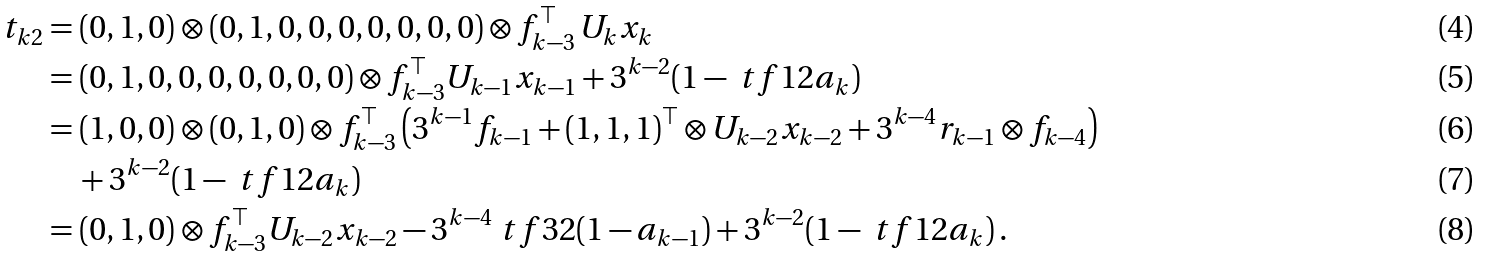<formula> <loc_0><loc_0><loc_500><loc_500>t _ { k 2 } & = ( 0 , 1 , 0 ) \otimes ( 0 , 1 , 0 , 0 , 0 , 0 , 0 , 0 , 0 ) \otimes f _ { k - 3 } ^ { \top } \, U _ { k } x _ { k } \\ & = ( 0 , 1 , 0 , 0 , 0 , 0 , 0 , 0 , 0 ) \otimes f _ { k - 3 } ^ { \top } U _ { k - 1 } x _ { k - 1 } + 3 ^ { k - 2 } ( 1 - \ t f 1 2 a _ { k } ) \\ & = ( 1 , 0 , 0 ) \otimes ( 0 , 1 , 0 ) \otimes f _ { k - 3 } ^ { \top } \left ( 3 ^ { k - 1 } f _ { k - 1 } + ( 1 , 1 , 1 ) ^ { \top } \otimes U _ { k - 2 } x _ { k - 2 } + 3 ^ { k - 4 } r _ { k - 1 } \otimes f _ { k - 4 } \right ) \\ & \quad + 3 ^ { k - 2 } ( 1 - \ t f 1 2 a _ { k } ) \\ & = ( 0 , 1 , 0 ) \otimes f _ { k - 3 } ^ { \top } U _ { k - 2 } x _ { k - 2 } - 3 ^ { k - 4 } \ t f 3 2 ( 1 - a _ { k - 1 } ) + 3 ^ { k - 2 } ( 1 - \ t f 1 2 a _ { k } ) \, .</formula> 